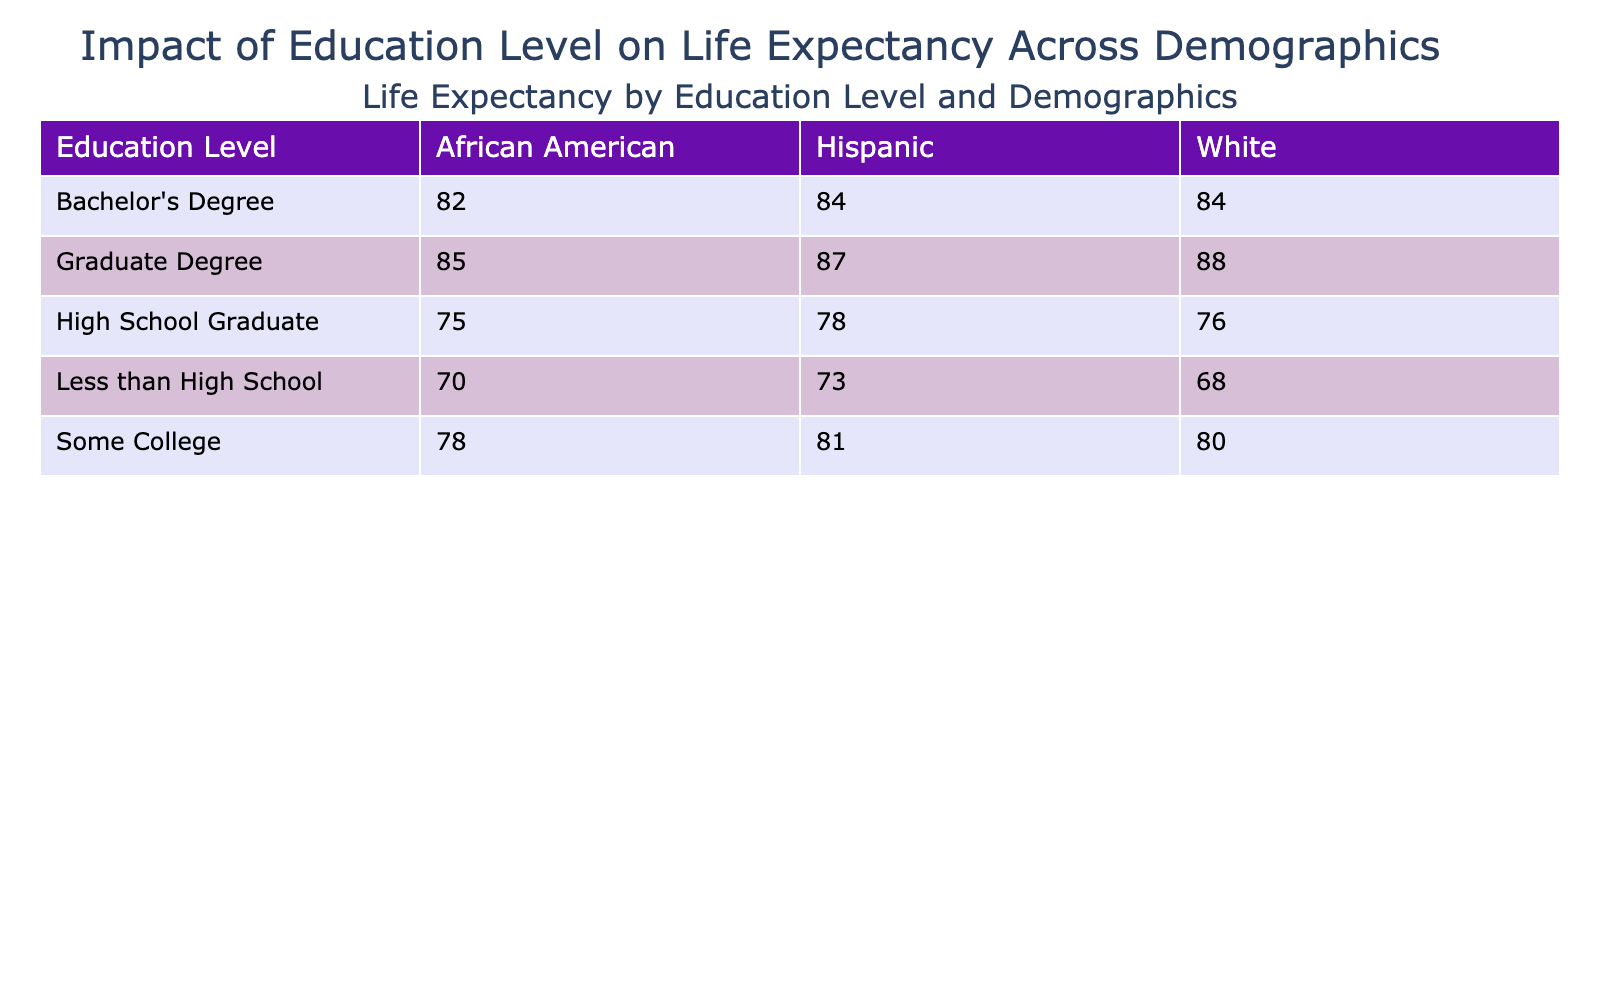What is the life expectancy for African Americans with a Bachelor's Degree? The table shows that the life expectancy for African Americans with a Bachelor's Degree is 82 years.
Answer: 82 What is the life expectancy of the demographic group with the highest education level? The demographic group with the highest education level is those with a Graduate Degree, and the life expectancy is 88 years for White individuals.
Answer: 88 How much longer do White individuals with a Graduate Degree live compared to those with less than a high school education? The life expectancy for White individuals with a Graduate Degree is 88 years, while for those with less than a high school education it is 68 years. The difference is 88 - 68 = 20 years.
Answer: 20 Is the life expectancy for a Hispanic with a Graduate Degree higher than that of an African American with a Bachelor's Degree? The life expectancy for Hispanics with a Graduate Degree is 87 years, and for African Americans with a Bachelor's Degree it is 82 years. Since 87 is greater than 82, the statement is true.
Answer: Yes What is the average life expectancy for individuals who have completed some college? For those who have completed some college, the life expectancies are 78 (African American), 81 (Hispanic), and 80 (White). The sum is 78 + 81 + 80 = 239. Dividing by 3 gives an average of 239 / 3 = 79.67 years.
Answer: 79.67 Which demographic group has the lowest life expectancy at the lowest education level? Among those with less than a high school education, the life expectancy for African Americans is 70 years, for Hispanics is 73 years, and for Whites is 68 years. The lowest is 68 years for White individuals.
Answer: 68 What is the difference in life expectancy between High School Graduates and those with a Graduate Degree among Hispanics? The life expectancy for Hispanic High School Graduates is 78 years, while for those with a Graduate Degree it is 87 years. The difference is 87 - 78 = 9 years.
Answer: 9 How do life expectancies for Hispanic individuals change from having less than a high school education to obtaining a Bachelor's Degree? Hispanics with less than a high school education have a life expectancy of 73 years, and those with a Bachelor's Degree have a life expectancy of 84 years. The increase is 84 - 73 = 11 years.
Answer: 11 